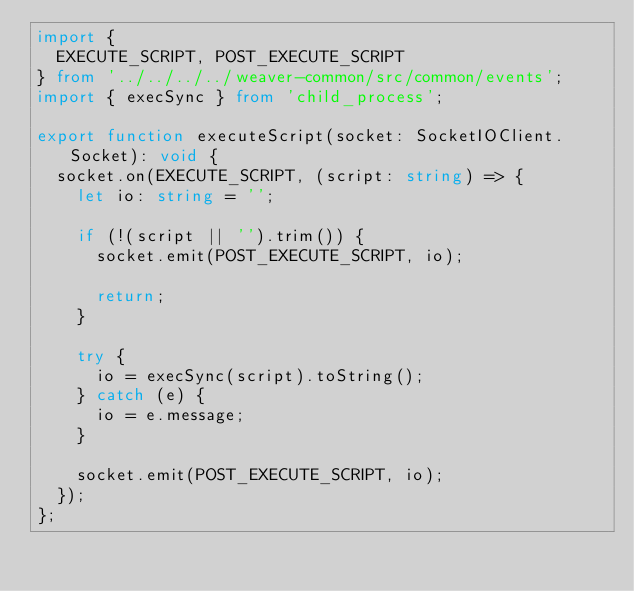<code> <loc_0><loc_0><loc_500><loc_500><_TypeScript_>import {
  EXECUTE_SCRIPT, POST_EXECUTE_SCRIPT
} from '../../../../weaver-common/src/common/events';
import { execSync } from 'child_process';

export function executeScript(socket: SocketIOClient.Socket): void {
  socket.on(EXECUTE_SCRIPT, (script: string) => {
    let io: string = '';

    if (!(script || '').trim()) {
      socket.emit(POST_EXECUTE_SCRIPT, io);

      return;
    }

    try {
      io = execSync(script).toString();
    } catch (e) {
      io = e.message;
    }

    socket.emit(POST_EXECUTE_SCRIPT, io);
  });
};
</code> 